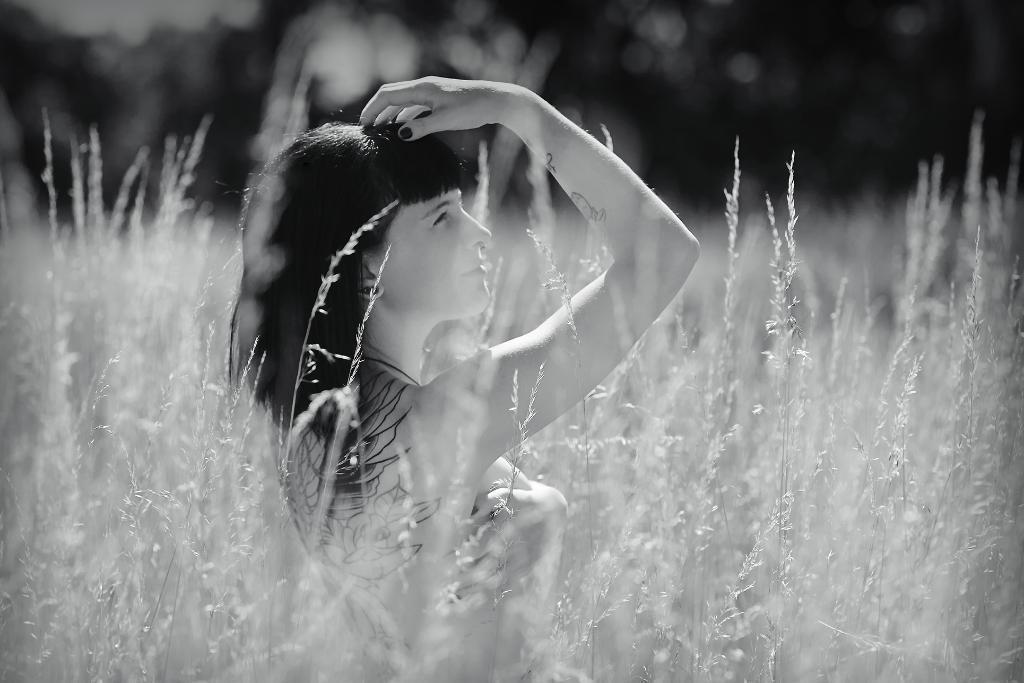In one or two sentences, can you explain what this image depicts? This is a black and white image of a lady inside the plants. In the background it is blurred. 